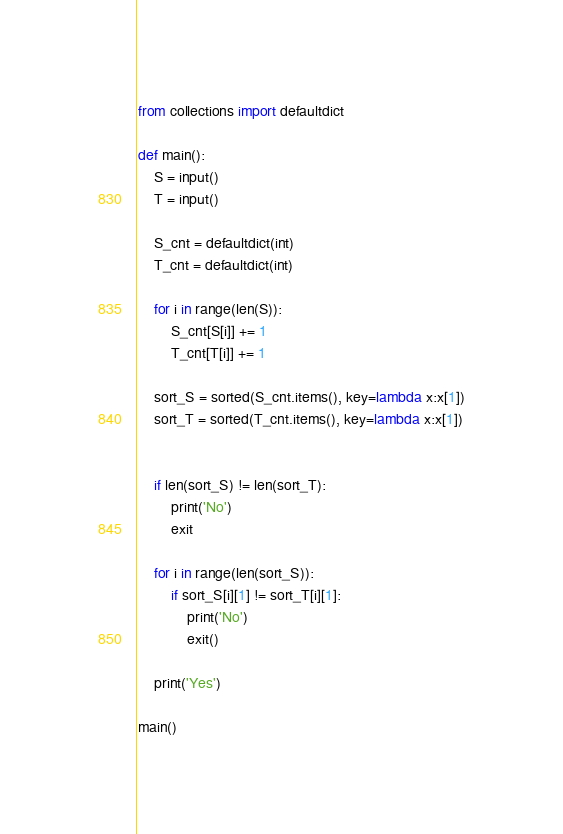<code> <loc_0><loc_0><loc_500><loc_500><_Python_>from collections import defaultdict

def main():
    S = input()
    T = input()

    S_cnt = defaultdict(int)
    T_cnt = defaultdict(int)

    for i in range(len(S)):
        S_cnt[S[i]] += 1
        T_cnt[T[i]] += 1

    sort_S = sorted(S_cnt.items(), key=lambda x:x[1])
    sort_T = sorted(T_cnt.items(), key=lambda x:x[1])


    if len(sort_S) != len(sort_T):
        print('No')
        exit

    for i in range(len(sort_S)):
        if sort_S[i][1] != sort_T[i][1]:
            print('No')
            exit()

    print('Yes')

main()</code> 